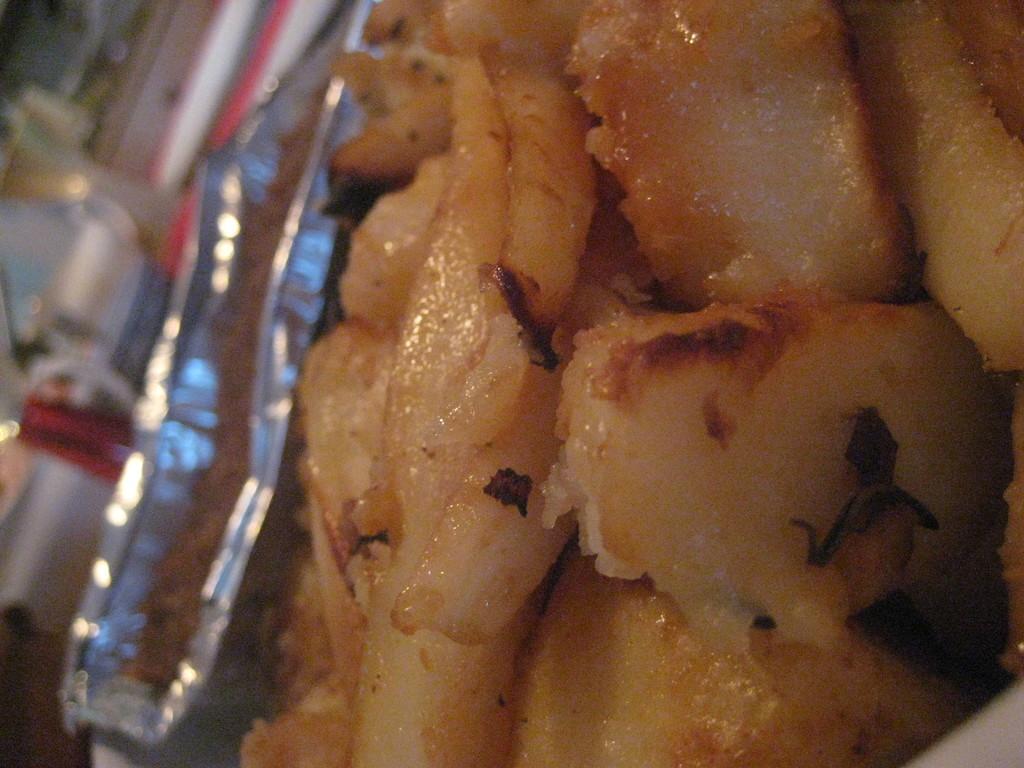How would you summarize this image in a sentence or two? This image consists of a box. It has eatables. 